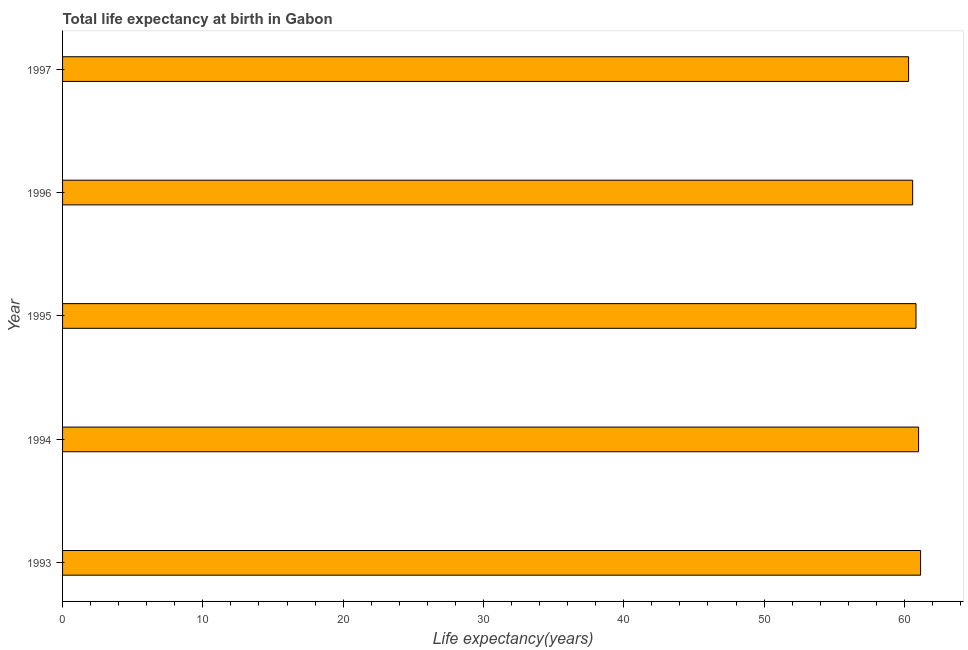Does the graph contain any zero values?
Your answer should be very brief. No. Does the graph contain grids?
Offer a terse response. No. What is the title of the graph?
Give a very brief answer. Total life expectancy at birth in Gabon. What is the label or title of the X-axis?
Offer a very short reply. Life expectancy(years). What is the label or title of the Y-axis?
Keep it short and to the point. Year. What is the life expectancy at birth in 1994?
Keep it short and to the point. 61.01. Across all years, what is the maximum life expectancy at birth?
Your answer should be very brief. 61.16. Across all years, what is the minimum life expectancy at birth?
Your response must be concise. 60.3. What is the sum of the life expectancy at birth?
Ensure brevity in your answer.  303.9. What is the difference between the life expectancy at birth in 1993 and 1996?
Make the answer very short. 0.56. What is the average life expectancy at birth per year?
Offer a very short reply. 60.78. What is the median life expectancy at birth?
Provide a succinct answer. 60.83. In how many years, is the life expectancy at birth greater than 58 years?
Offer a very short reply. 5. Is the difference between the life expectancy at birth in 1994 and 1997 greater than the difference between any two years?
Provide a short and direct response. No. What is the difference between the highest and the second highest life expectancy at birth?
Your answer should be very brief. 0.14. Is the sum of the life expectancy at birth in 1993 and 1994 greater than the maximum life expectancy at birth across all years?
Provide a succinct answer. Yes. What is the difference between the highest and the lowest life expectancy at birth?
Your answer should be very brief. 0.85. How many bars are there?
Offer a terse response. 5. Are all the bars in the graph horizontal?
Provide a succinct answer. Yes. How many years are there in the graph?
Your answer should be very brief. 5. Are the values on the major ticks of X-axis written in scientific E-notation?
Give a very brief answer. No. What is the Life expectancy(years) in 1993?
Ensure brevity in your answer.  61.16. What is the Life expectancy(years) in 1994?
Make the answer very short. 61.01. What is the Life expectancy(years) in 1995?
Your response must be concise. 60.83. What is the Life expectancy(years) in 1996?
Give a very brief answer. 60.59. What is the Life expectancy(years) in 1997?
Your answer should be very brief. 60.3. What is the difference between the Life expectancy(years) in 1993 and 1994?
Provide a short and direct response. 0.14. What is the difference between the Life expectancy(years) in 1993 and 1995?
Keep it short and to the point. 0.33. What is the difference between the Life expectancy(years) in 1993 and 1996?
Keep it short and to the point. 0.56. What is the difference between the Life expectancy(years) in 1993 and 1997?
Ensure brevity in your answer.  0.85. What is the difference between the Life expectancy(years) in 1994 and 1995?
Make the answer very short. 0.19. What is the difference between the Life expectancy(years) in 1994 and 1996?
Ensure brevity in your answer.  0.42. What is the difference between the Life expectancy(years) in 1994 and 1997?
Your response must be concise. 0.71. What is the difference between the Life expectancy(years) in 1995 and 1996?
Provide a short and direct response. 0.24. What is the difference between the Life expectancy(years) in 1995 and 1997?
Your response must be concise. 0.53. What is the difference between the Life expectancy(years) in 1996 and 1997?
Make the answer very short. 0.29. What is the ratio of the Life expectancy(years) in 1993 to that in 1994?
Ensure brevity in your answer.  1. What is the ratio of the Life expectancy(years) in 1993 to that in 1995?
Provide a succinct answer. 1. What is the ratio of the Life expectancy(years) in 1993 to that in 1997?
Give a very brief answer. 1.01. What is the ratio of the Life expectancy(years) in 1994 to that in 1995?
Your response must be concise. 1. What is the ratio of the Life expectancy(years) in 1994 to that in 1996?
Offer a very short reply. 1.01. What is the ratio of the Life expectancy(years) in 1994 to that in 1997?
Give a very brief answer. 1.01. What is the ratio of the Life expectancy(years) in 1995 to that in 1997?
Make the answer very short. 1.01. 